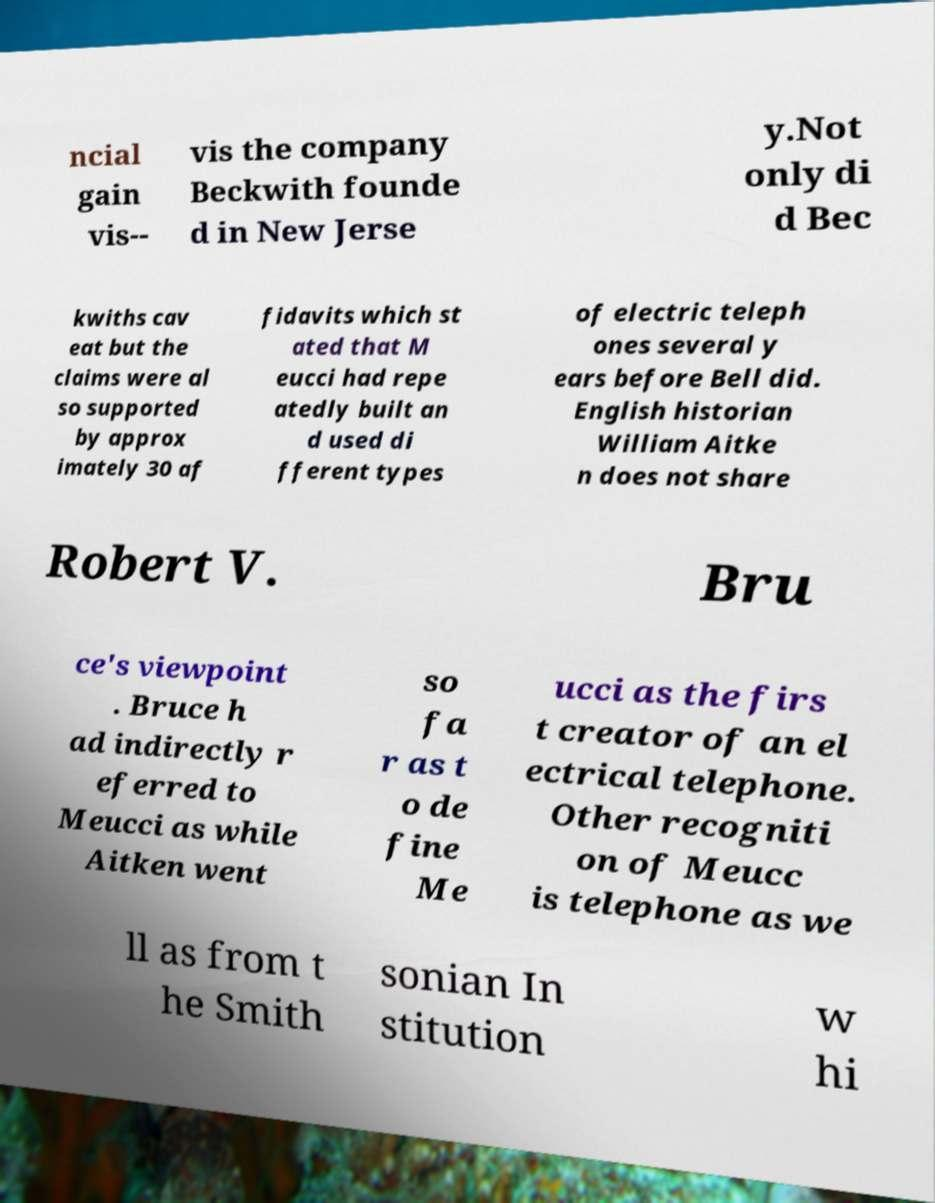For documentation purposes, I need the text within this image transcribed. Could you provide that? ncial gain vis-- vis the company Beckwith founde d in New Jerse y.Not only di d Bec kwiths cav eat but the claims were al so supported by approx imately 30 af fidavits which st ated that M eucci had repe atedly built an d used di fferent types of electric teleph ones several y ears before Bell did. English historian William Aitke n does not share Robert V. Bru ce's viewpoint . Bruce h ad indirectly r eferred to Meucci as while Aitken went so fa r as t o de fine Me ucci as the firs t creator of an el ectrical telephone. Other recogniti on of Meucc is telephone as we ll as from t he Smith sonian In stitution w hi 